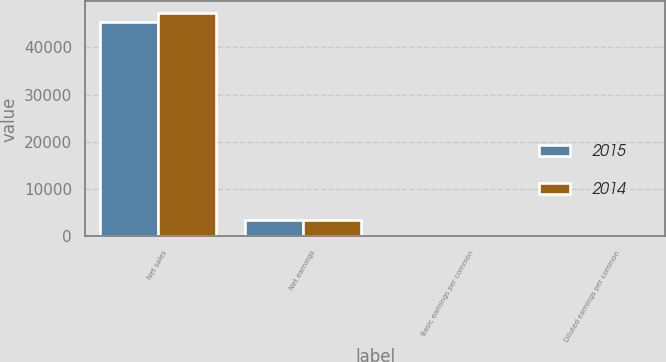Convert chart to OTSL. <chart><loc_0><loc_0><loc_500><loc_500><stacked_bar_chart><ecel><fcel>Net sales<fcel>Net earnings<fcel>Basic earnings per common<fcel>Diluted earnings per common<nl><fcel>2015<fcel>45366<fcel>3534<fcel>11.39<fcel>11.23<nl><fcel>2014<fcel>47369<fcel>3475<fcel>10.97<fcel>10.78<nl></chart> 